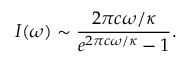Convert formula to latex. <formula><loc_0><loc_0><loc_500><loc_500>I ( \omega ) \sim \frac { 2 \pi c \omega / \kappa } { e ^ { 2 \pi c \omega / \kappa } - 1 } .</formula> 